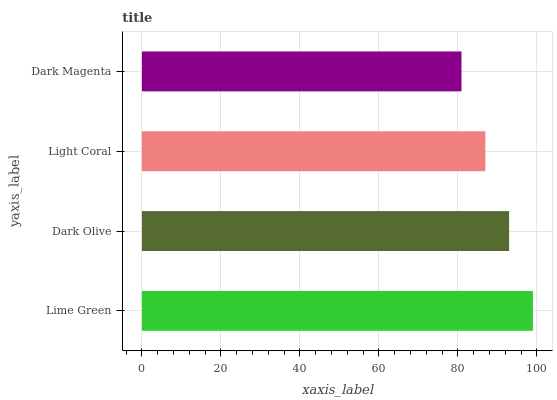Is Dark Magenta the minimum?
Answer yes or no. Yes. Is Lime Green the maximum?
Answer yes or no. Yes. Is Dark Olive the minimum?
Answer yes or no. No. Is Dark Olive the maximum?
Answer yes or no. No. Is Lime Green greater than Dark Olive?
Answer yes or no. Yes. Is Dark Olive less than Lime Green?
Answer yes or no. Yes. Is Dark Olive greater than Lime Green?
Answer yes or no. No. Is Lime Green less than Dark Olive?
Answer yes or no. No. Is Dark Olive the high median?
Answer yes or no. Yes. Is Light Coral the low median?
Answer yes or no. Yes. Is Lime Green the high median?
Answer yes or no. No. Is Dark Olive the low median?
Answer yes or no. No. 